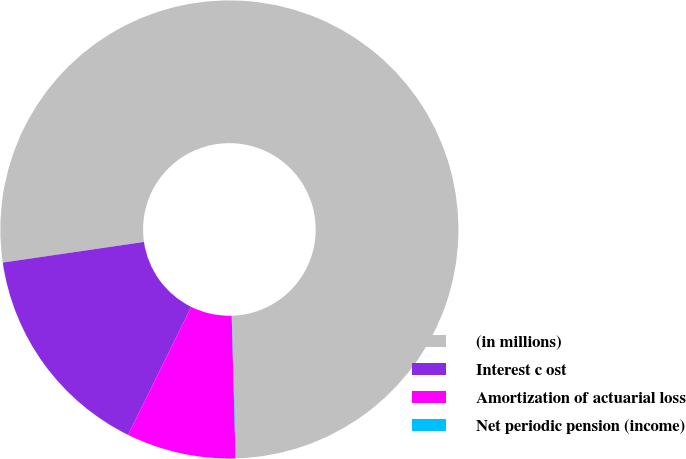Convert chart to OTSL. <chart><loc_0><loc_0><loc_500><loc_500><pie_chart><fcel>(in millions)<fcel>Interest c ost<fcel>Amortization of actuarial loss<fcel>Net periodic pension (income)<nl><fcel>76.84%<fcel>15.4%<fcel>7.72%<fcel>0.04%<nl></chart> 